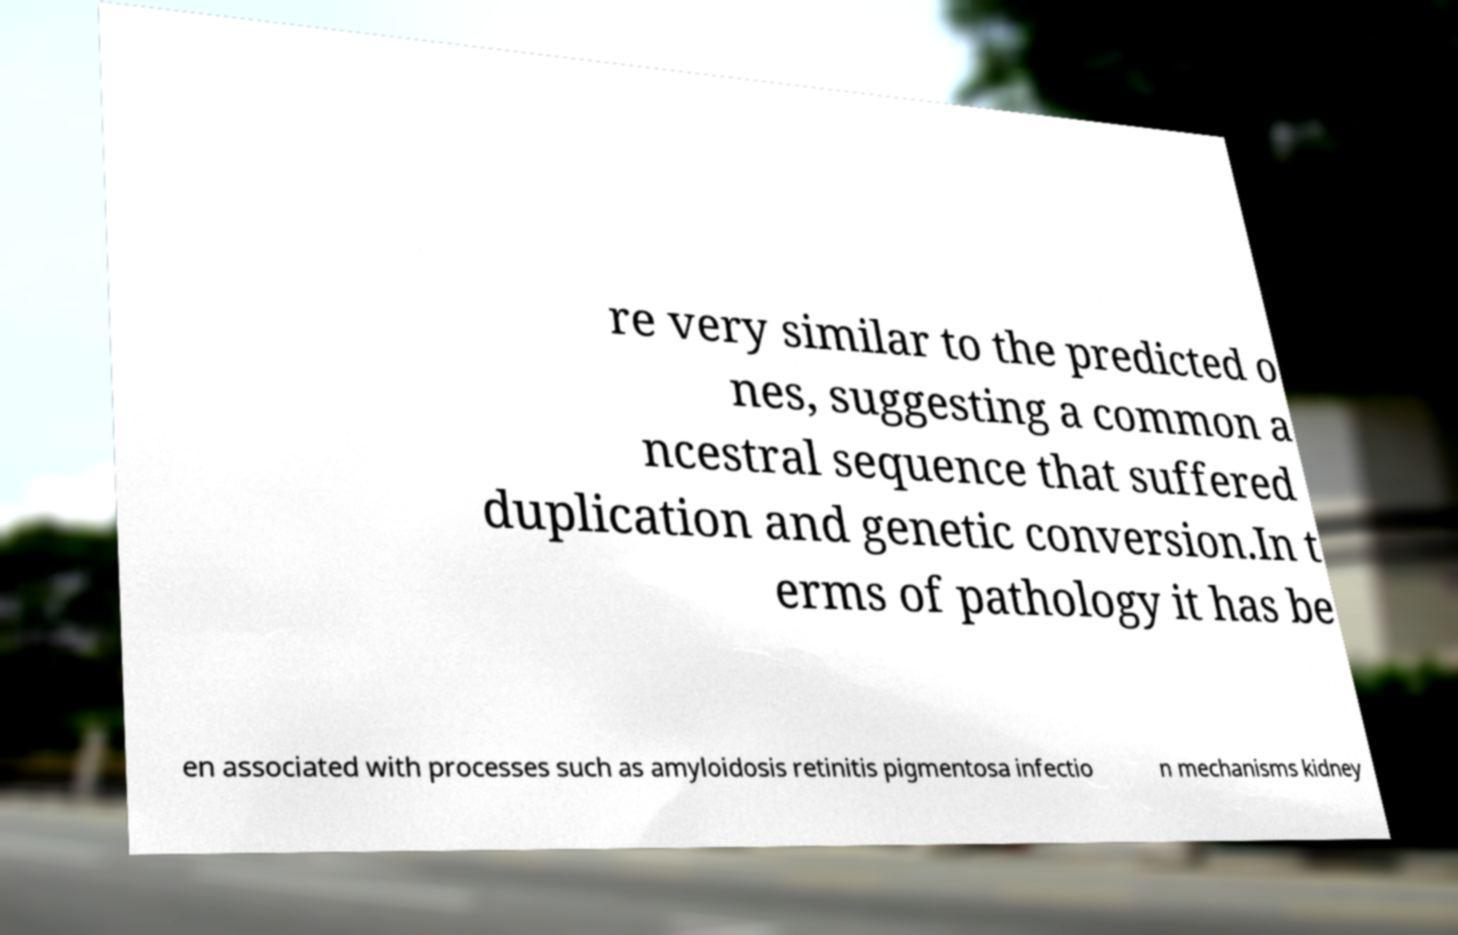Can you accurately transcribe the text from the provided image for me? re very similar to the predicted o nes, suggesting a common a ncestral sequence that suffered duplication and genetic conversion.In t erms of pathology it has be en associated with processes such as amyloidosis retinitis pigmentosa infectio n mechanisms kidney 